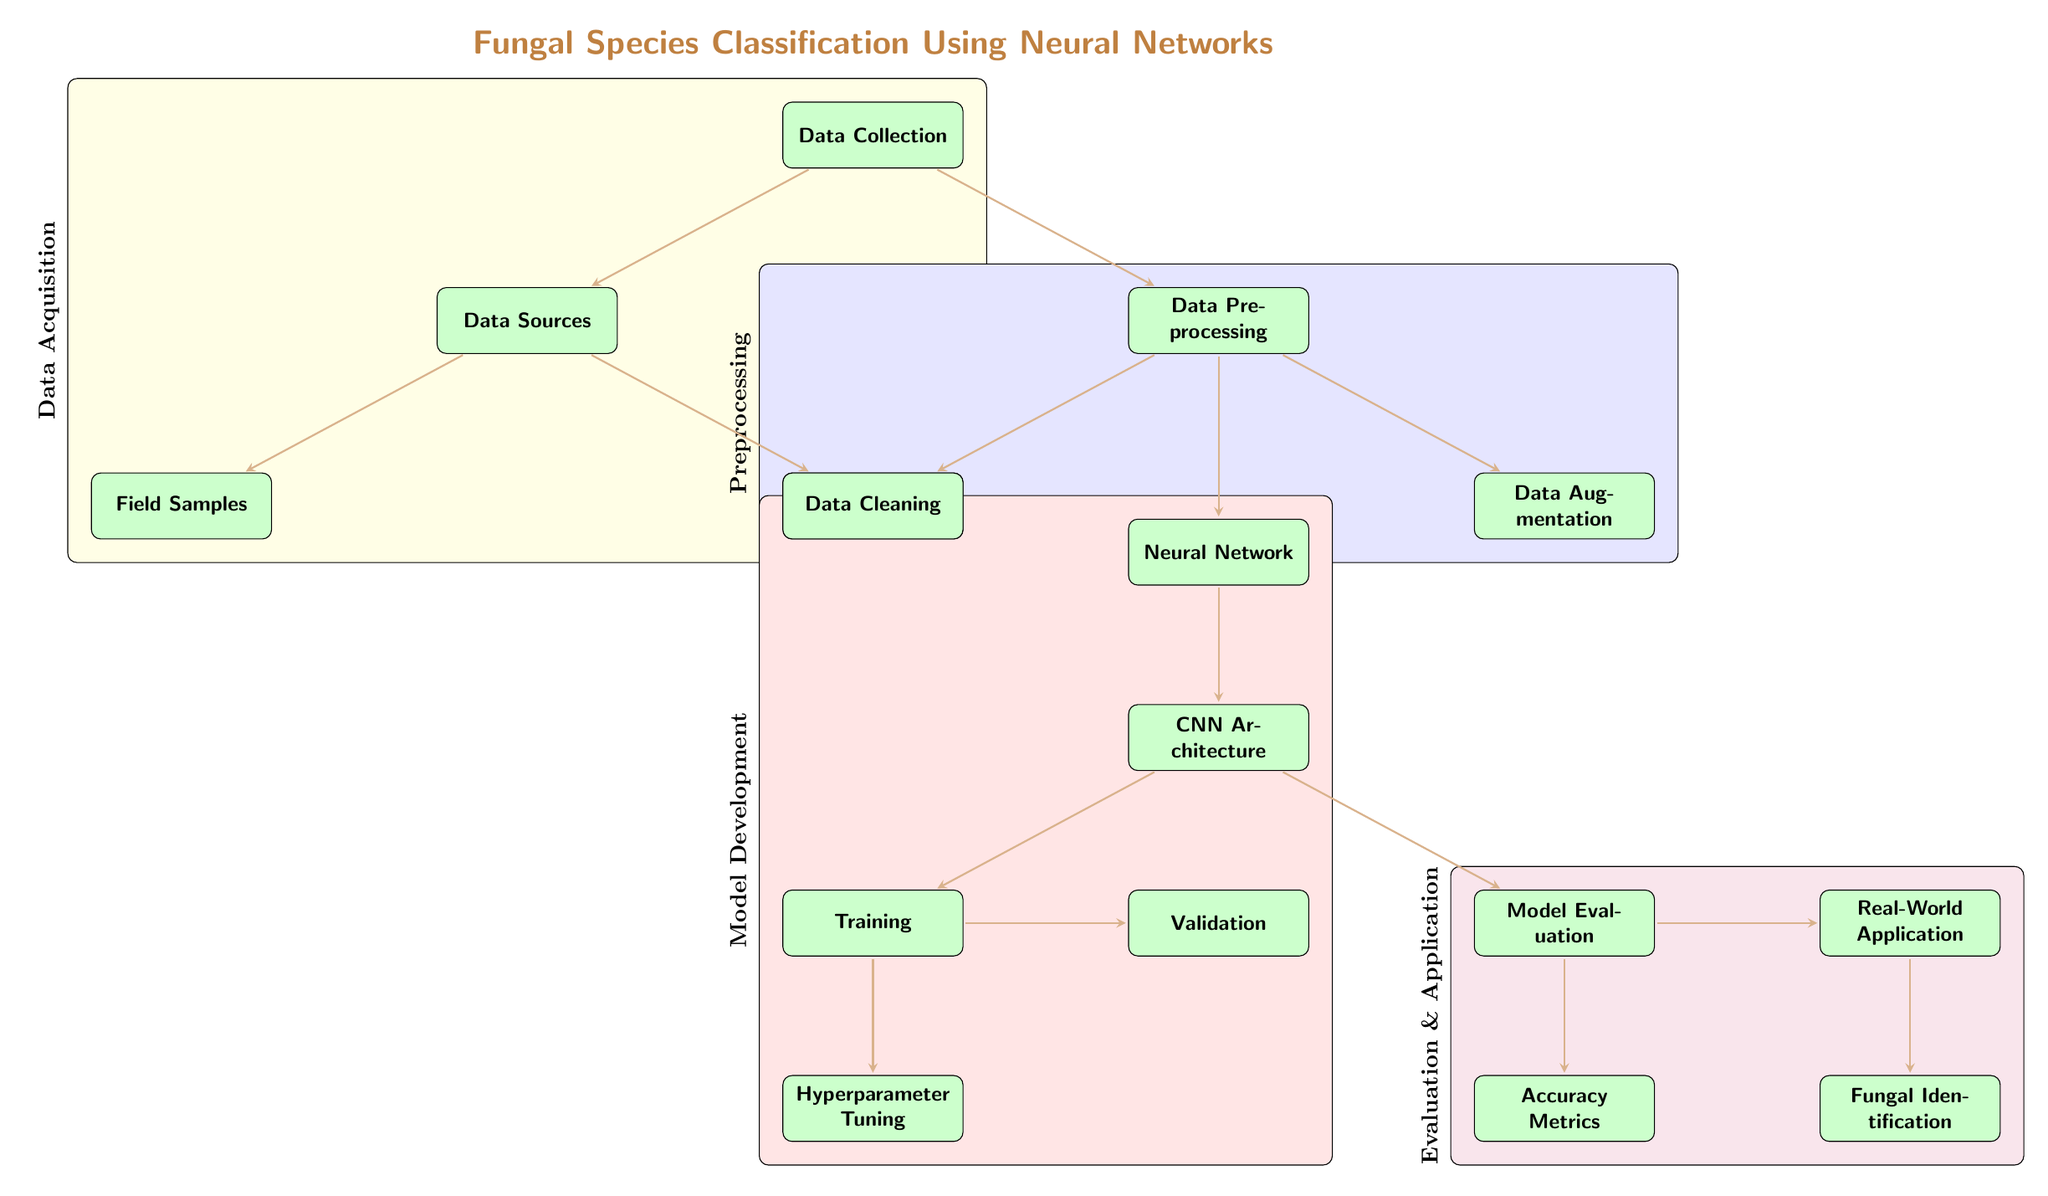What is the first step in the process? The first step in the diagram is labeled as "Data Collection." This node is positioned at the top of the diagram, indicating it as the starting point of the classification process.
Answer: Data Collection How many nodes are grouped under "Preprocessing"? The "Preprocessing" group contains three nodes: "Data Cleaning," "Data Augmentation," and the arrow leading down to the "Neural Network" node, which indicates their connection to the preprocessing stage.
Answer: Three What follows the "Neural Network" node? The node that follows the "Neural Network" node is "CNN Architecture," reflecting the next phase in the process after establishing the network framework.
Answer: CNN Architecture Which two nodes are connected directly to the "Training" node? The nodes directly connected to "Training" are "Hyperparameter Tuning" and "Validation," both stemming from the "Training" node, indicating the next steps involved in refining the model.
Answer: Hyperparameter Tuning and Validation What is the final outcome achieved after "Real-World Application"? The final outcome mentioned in the diagram after "Real-World Application" is "Fungal Identification," indicating the ultimate goal of the process.
Answer: Fungal Identification What layer is the "Model Evaluation" node part of? The "Model Evaluation" node falls under the "Evaluation & Application" layer, which groups other related nodes, emphasizing its role in assessing the model's performance.
Answer: Evaluation & Application Which node represents the augmentation of data? The node dedicated to the augmentation of data is labeled "Data Augmentation," illustrating its role in enhancing the dataset prior to training the model.
Answer: Data Augmentation In which section does "Accuracy Metrics" reside? "Accuracy Metrics" is located in the "Evaluation & Application" section, indicating its importance in measuring the effectiveness of the model after it has been trained and validated.
Answer: Evaluation & Application 